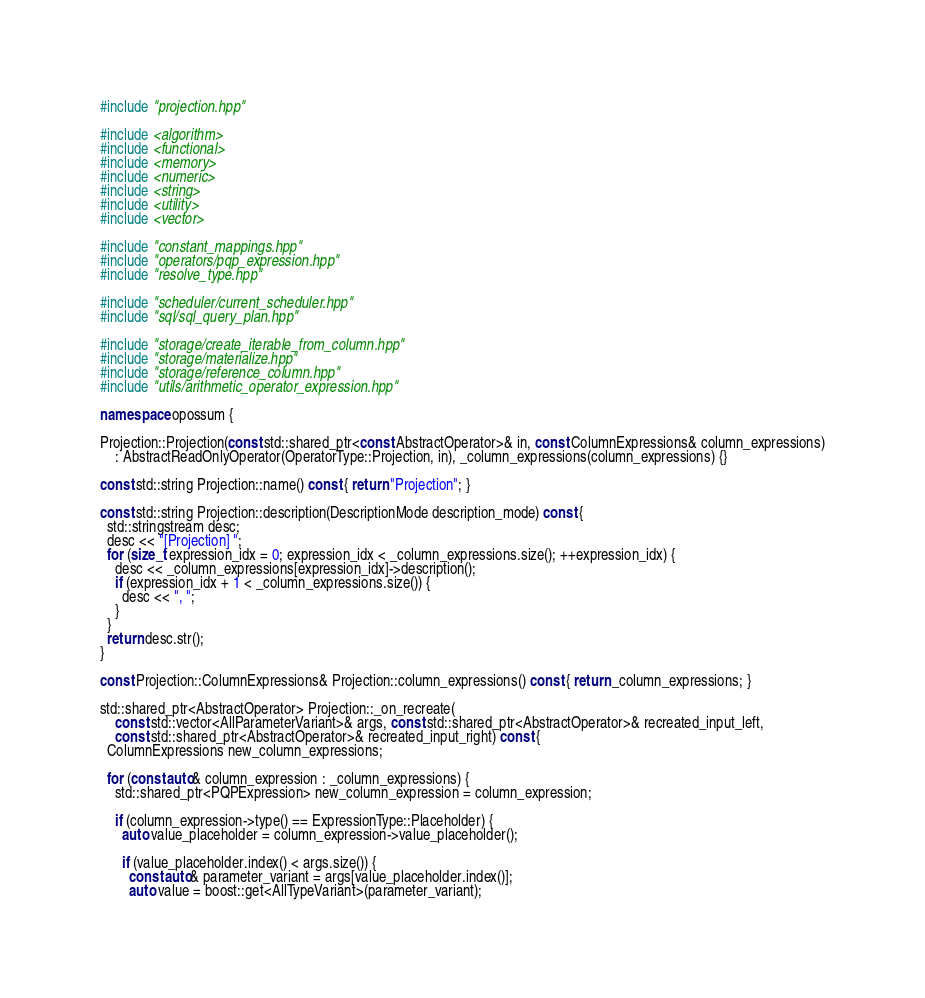Convert code to text. <code><loc_0><loc_0><loc_500><loc_500><_C++_>#include "projection.hpp"

#include <algorithm>
#include <functional>
#include <memory>
#include <numeric>
#include <string>
#include <utility>
#include <vector>

#include "constant_mappings.hpp"
#include "operators/pqp_expression.hpp"
#include "resolve_type.hpp"

#include "scheduler/current_scheduler.hpp"
#include "sql/sql_query_plan.hpp"

#include "storage/create_iterable_from_column.hpp"
#include "storage/materialize.hpp"
#include "storage/reference_column.hpp"
#include "utils/arithmetic_operator_expression.hpp"

namespace opossum {

Projection::Projection(const std::shared_ptr<const AbstractOperator>& in, const ColumnExpressions& column_expressions)
    : AbstractReadOnlyOperator(OperatorType::Projection, in), _column_expressions(column_expressions) {}

const std::string Projection::name() const { return "Projection"; }

const std::string Projection::description(DescriptionMode description_mode) const {
  std::stringstream desc;
  desc << "[Projection] ";
  for (size_t expression_idx = 0; expression_idx < _column_expressions.size(); ++expression_idx) {
    desc << _column_expressions[expression_idx]->description();
    if (expression_idx + 1 < _column_expressions.size()) {
      desc << ", ";
    }
  }
  return desc.str();
}

const Projection::ColumnExpressions& Projection::column_expressions() const { return _column_expressions; }

std::shared_ptr<AbstractOperator> Projection::_on_recreate(
    const std::vector<AllParameterVariant>& args, const std::shared_ptr<AbstractOperator>& recreated_input_left,
    const std::shared_ptr<AbstractOperator>& recreated_input_right) const {
  ColumnExpressions new_column_expressions;

  for (const auto& column_expression : _column_expressions) {
    std::shared_ptr<PQPExpression> new_column_expression = column_expression;

    if (column_expression->type() == ExpressionType::Placeholder) {
      auto value_placeholder = column_expression->value_placeholder();

      if (value_placeholder.index() < args.size()) {
        const auto& parameter_variant = args[value_placeholder.index()];
        auto value = boost::get<AllTypeVariant>(parameter_variant);</code> 